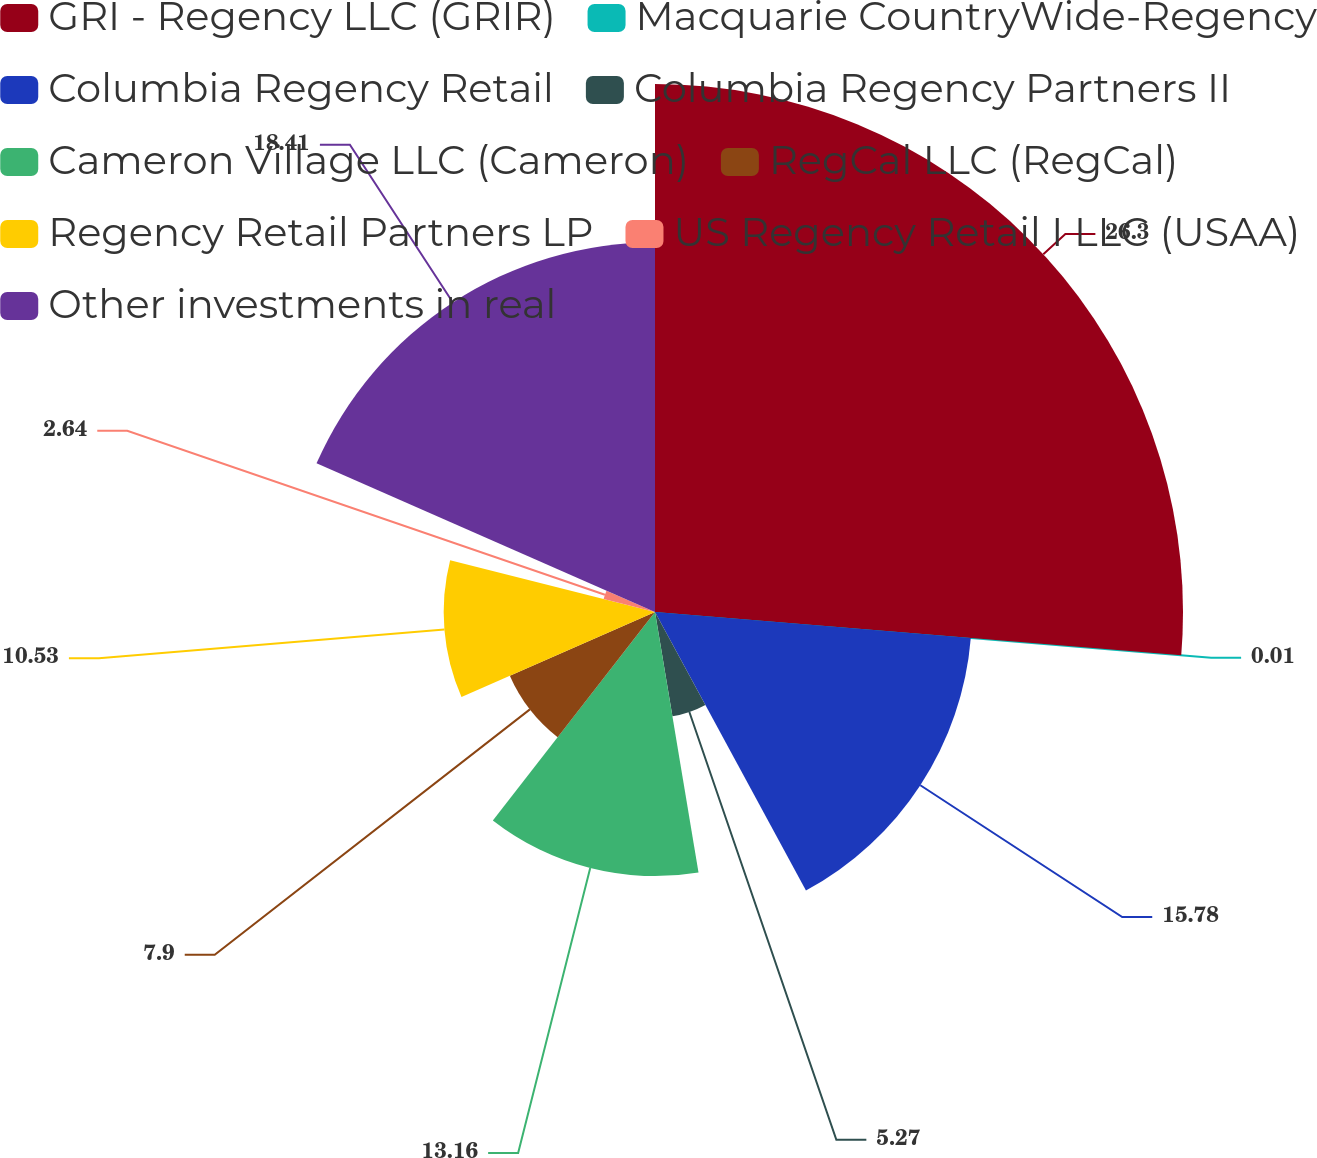Convert chart to OTSL. <chart><loc_0><loc_0><loc_500><loc_500><pie_chart><fcel>GRI - Regency LLC (GRIR)<fcel>Macquarie CountryWide-Regency<fcel>Columbia Regency Retail<fcel>Columbia Regency Partners II<fcel>Cameron Village LLC (Cameron)<fcel>RegCal LLC (RegCal)<fcel>Regency Retail Partners LP<fcel>US Regency Retail I LLC (USAA)<fcel>Other investments in real<nl><fcel>26.31%<fcel>0.01%<fcel>15.79%<fcel>5.27%<fcel>13.16%<fcel>7.9%<fcel>10.53%<fcel>2.64%<fcel>18.42%<nl></chart> 